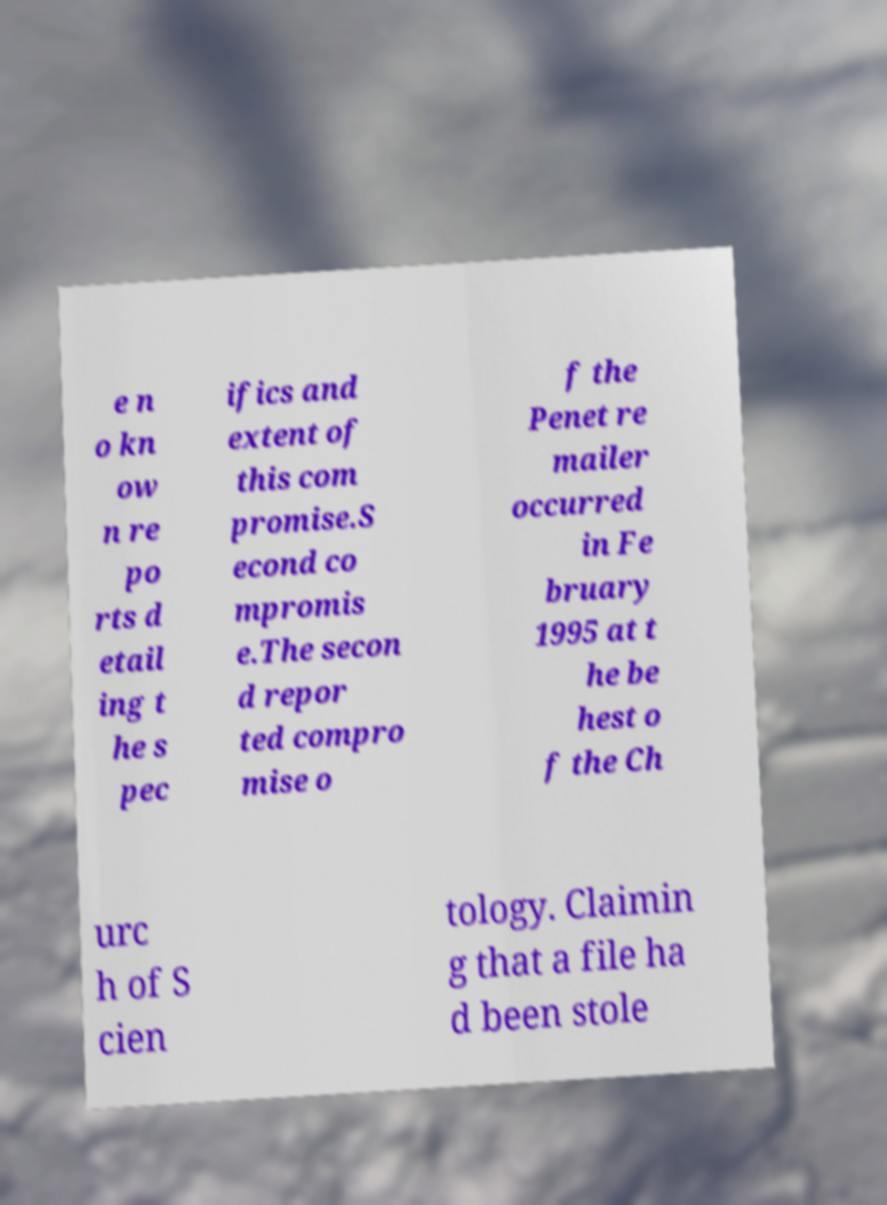What messages or text are displayed in this image? I need them in a readable, typed format. e n o kn ow n re po rts d etail ing t he s pec ifics and extent of this com promise.S econd co mpromis e.The secon d repor ted compro mise o f the Penet re mailer occurred in Fe bruary 1995 at t he be hest o f the Ch urc h of S cien tology. Claimin g that a file ha d been stole 